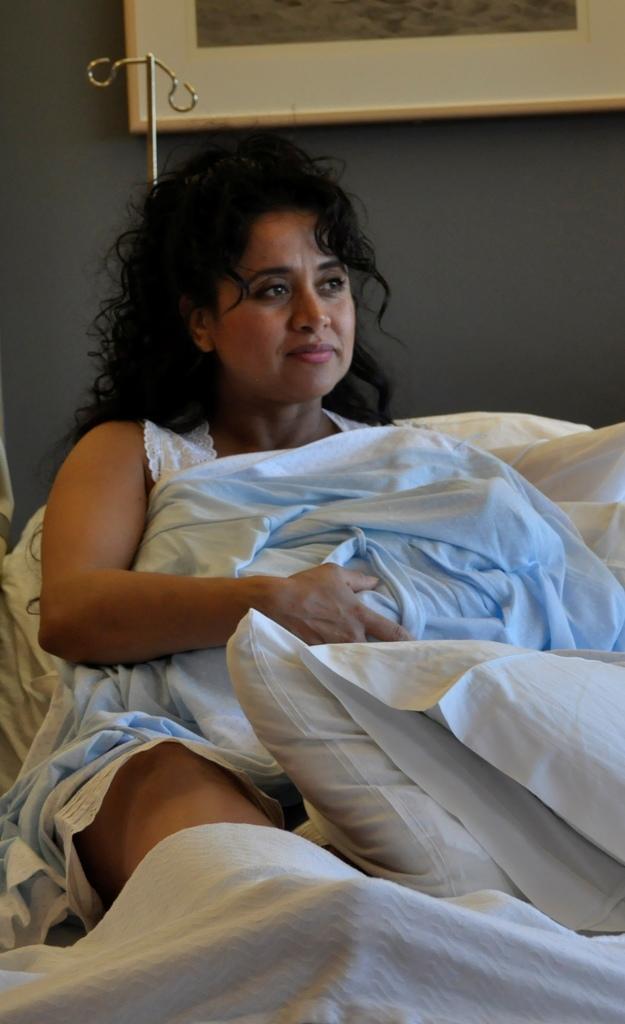Please provide a concise description of this image. The woman in white dress is sitting on the bed. She is holding a white color bed sheet in her hands. In front of the picture, we see white pillows and a white bed sheet. Behind her, we see a photo frame is placed on the wall. We even see a saline stand. 